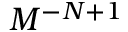<formula> <loc_0><loc_0><loc_500><loc_500>M ^ { - N + 1 }</formula> 